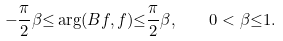Convert formula to latex. <formula><loc_0><loc_0><loc_500><loc_500>- \frac { \pi } { 2 } \beta { \leq } \arg ( B f , f ) { \leq } \frac { \pi } { 2 } \beta , \quad 0 < \beta { \leq } 1 .</formula> 